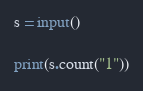<code> <loc_0><loc_0><loc_500><loc_500><_Python_>s = input()

print(s.count("1"))</code> 